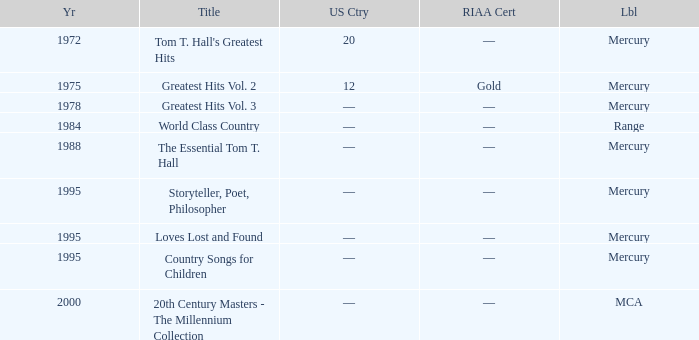What label had the album after 1978? Range, Mercury, Mercury, Mercury, Mercury, MCA. 